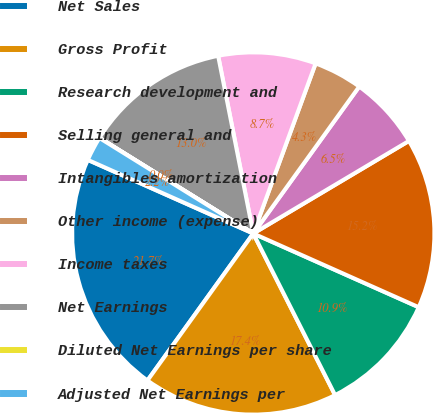Convert chart to OTSL. <chart><loc_0><loc_0><loc_500><loc_500><pie_chart><fcel>Net Sales<fcel>Gross Profit<fcel>Research development and<fcel>Selling general and<fcel>Intangibles amortization<fcel>Other income (expense)<fcel>Income taxes<fcel>Net Earnings<fcel>Diluted Net Earnings per share<fcel>Adjusted Net Earnings per<nl><fcel>21.73%<fcel>17.39%<fcel>10.87%<fcel>15.21%<fcel>6.52%<fcel>4.35%<fcel>8.7%<fcel>13.04%<fcel>0.01%<fcel>2.18%<nl></chart> 